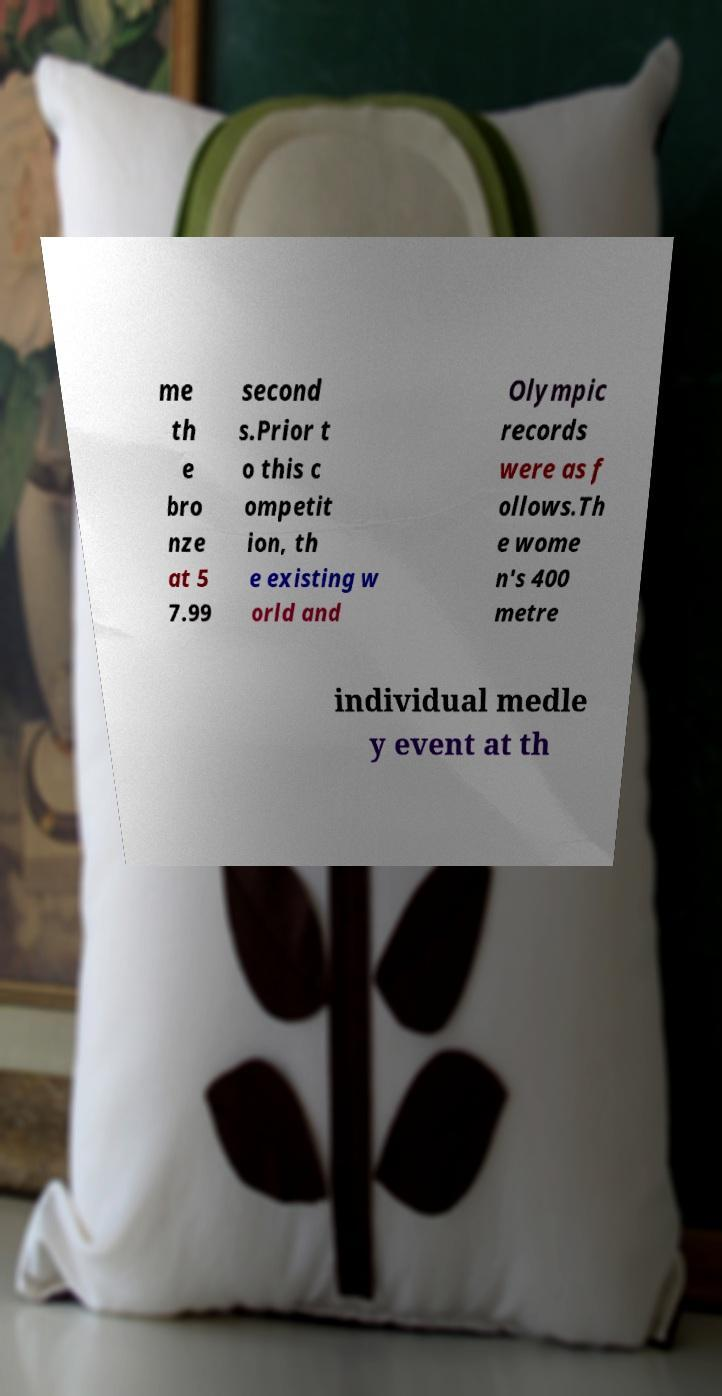Can you read and provide the text displayed in the image?This photo seems to have some interesting text. Can you extract and type it out for me? me th e bro nze at 5 7.99 second s.Prior t o this c ompetit ion, th e existing w orld and Olympic records were as f ollows.Th e wome n's 400 metre individual medle y event at th 